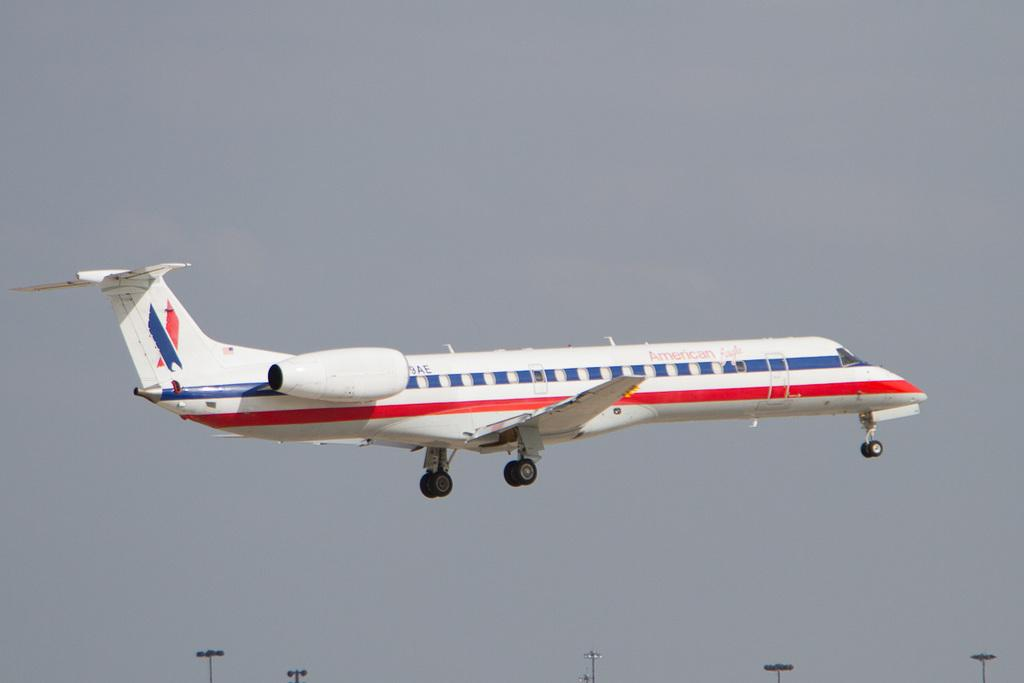What is the main subject of the image? The main subject of the image is an airplane flying in the sky. What else can be seen in the image besides the airplane? There are light poles visible in the image. Is there a cannon being fired in the image? No, there is no cannon or any indication of a cannon being fired in the image. Is there a spy observing the airplane in the image? No, there is no indication of a spy or any person observing the airplane in the image. 